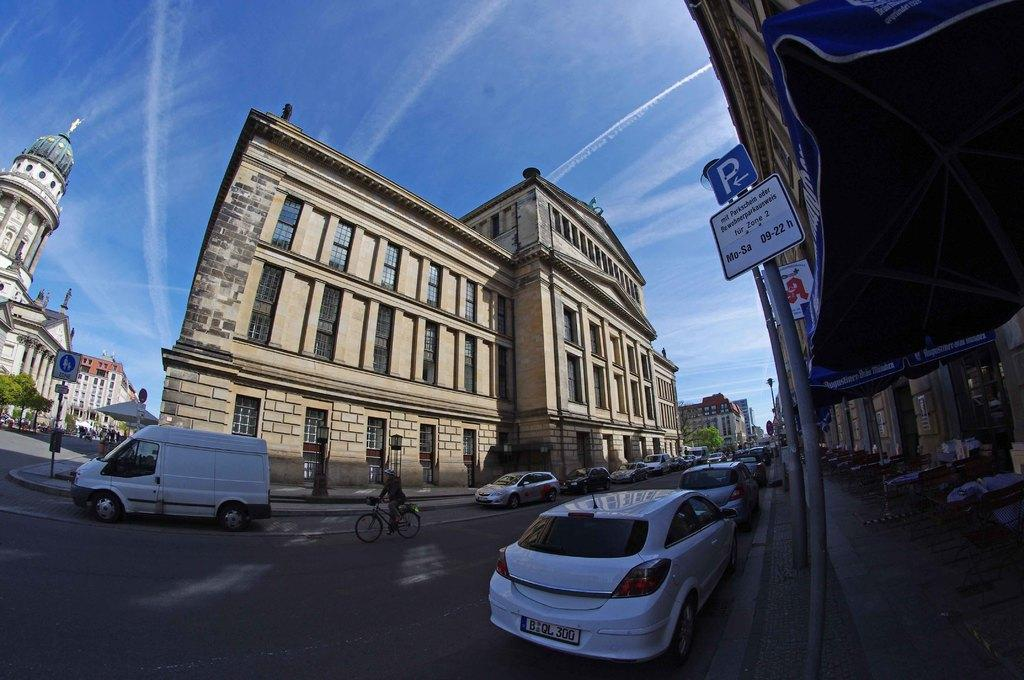What type of structures can be seen in the image? There are buildings in the image. What else can be seen in the image besides buildings? There are sign poles, a bicycle, vehicles, a tree, and windows visible in the image. Can you describe the transportation options in the image? There are vehicles and a bicycle in the image. What is visible at the top of the image? The sky is visible at the top of the image. What type of tooth is visible in the image? There is no tooth present in the image. What emotion is being expressed by the tree in the image? Trees do not express emotions, so this question cannot be answered. 